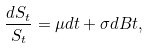<formula> <loc_0><loc_0><loc_500><loc_500>\frac { d S _ { t } } { S _ { t } } = \mu d t + \sigma d B t ,</formula> 